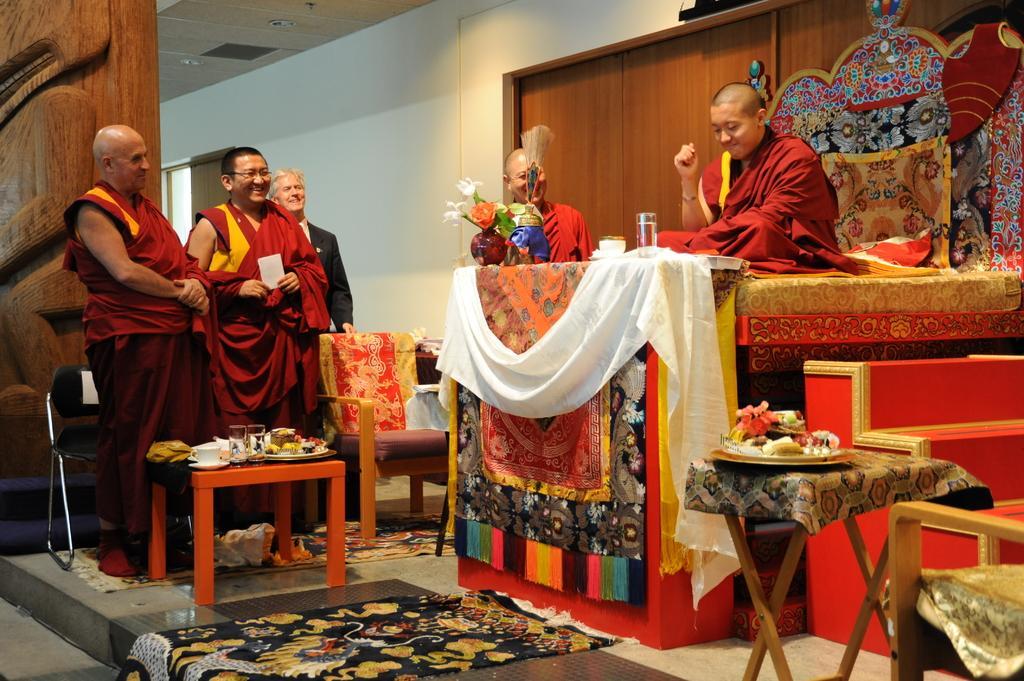In one or two sentences, can you explain what this image depicts? These persons are standing and holds a smile. This person is sitting on a chair. In-front of this person there is a table, on this table there is a cloth, flower vase, cup and glass. We can able to see chair, beside the chair there is a table, on this table there is a cup saucer, glasses and plate. 